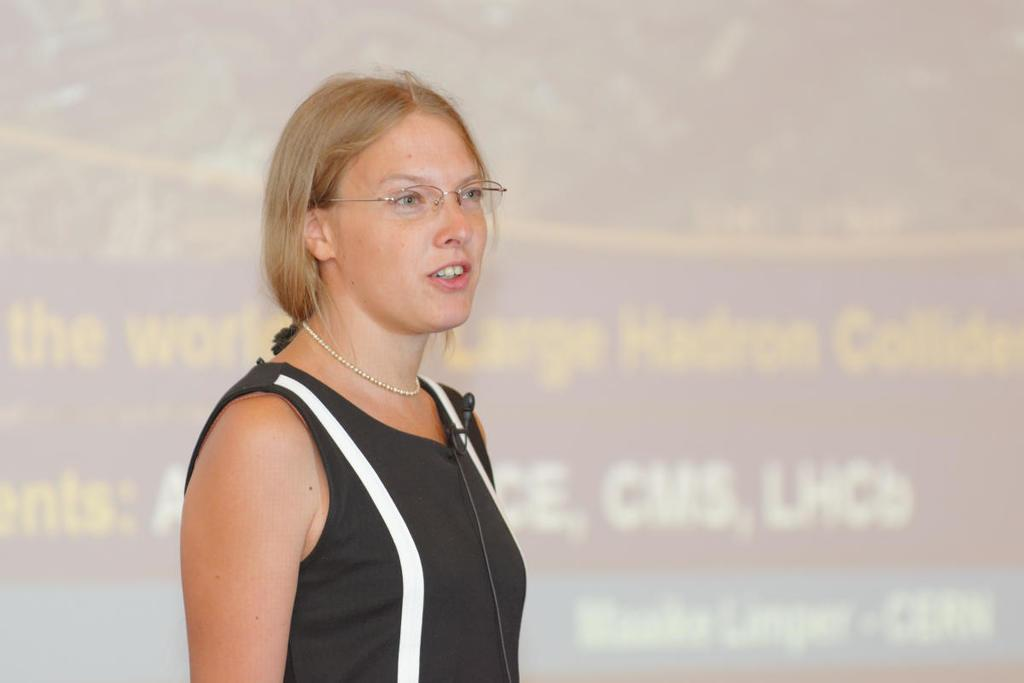What is the woman in the image doing? The woman is standing in the image. What can be seen on the woman's face? The woman is wearing spectacles. What object is the woman holding in the image? The woman is holding a microphone. What can be seen in the background of the image? There is a screen visible in the background of the image. What type of trousers is the woman wearing in the image? There is no information about the woman's trousers in the provided facts, so we cannot determine what type she is wearing. What value does the woman place on the project during the discussion? There is no indication of a meeting or discussion in the image, nor any information about the woman's opinion on a project. 